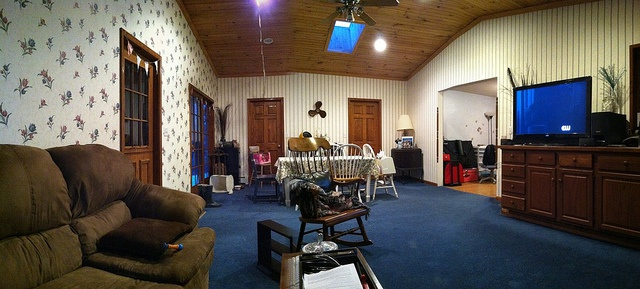Describe the objects in this image and their specific colors. I can see couch in gray, black, and maroon tones, tv in gray, darkblue, black, navy, and blue tones, chair in gray, black, blue, and maroon tones, potted plant in gray, black, olive, and khaki tones, and chair in gray, black, darkgray, and lightgray tones in this image. 